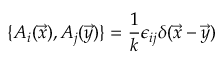<formula> <loc_0><loc_0><loc_500><loc_500>\{ A _ { i } ( \vec { x } ) , A _ { j } ( \vec { y } ) \} = \frac { 1 } { k } \epsilon _ { i j } \delta ( \vec { x } - \vec { y } )</formula> 